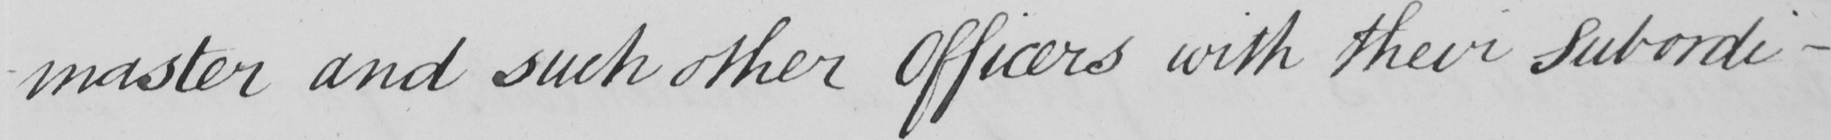Please provide the text content of this handwritten line. -master and such other Officers with their Subordi- 